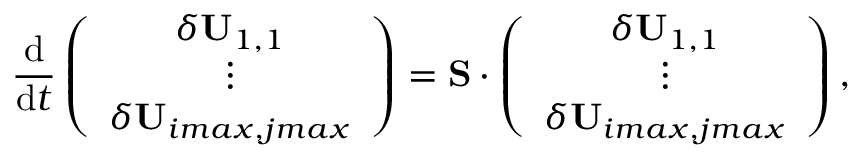Convert formula to latex. <formula><loc_0><loc_0><loc_500><loc_500>\frac { d } { d t } \left ( \begin{array} { c } { \delta U _ { 1 , 1 } } \\ { \vdots } \\ { \delta U _ { i \max , j \max } } \end{array} \right ) = S \cdot \left ( \begin{array} { c } { \delta U _ { 1 , 1 } } \\ { \vdots } \\ { \delta U _ { i \max , j \max } } \end{array} \right ) ,</formula> 